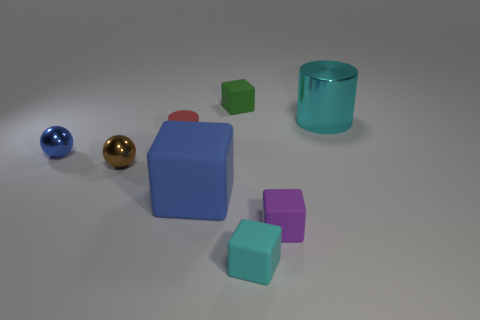Is the number of tiny green things left of the brown object the same as the number of blue things?
Your response must be concise. No. How many other things are the same shape as the tiny red matte object?
Keep it short and to the point. 1. The red object has what shape?
Make the answer very short. Cylinder. Do the red cylinder and the tiny cyan cube have the same material?
Your answer should be very brief. Yes. Are there an equal number of blue blocks that are to the left of the large matte thing and cyan cylinders that are in front of the cyan shiny thing?
Provide a succinct answer. Yes. Are there any green cubes that are left of the small matte block that is behind the metallic thing that is to the right of the large matte thing?
Offer a very short reply. No. Does the brown thing have the same size as the green rubber cube?
Offer a very short reply. Yes. There is a block behind the big thing that is right of the small rubber cube that is behind the red rubber thing; what color is it?
Give a very brief answer. Green. What number of large matte blocks have the same color as the tiny rubber cylinder?
Your answer should be very brief. 0. How many large things are brown rubber blocks or brown metallic balls?
Your response must be concise. 0. 